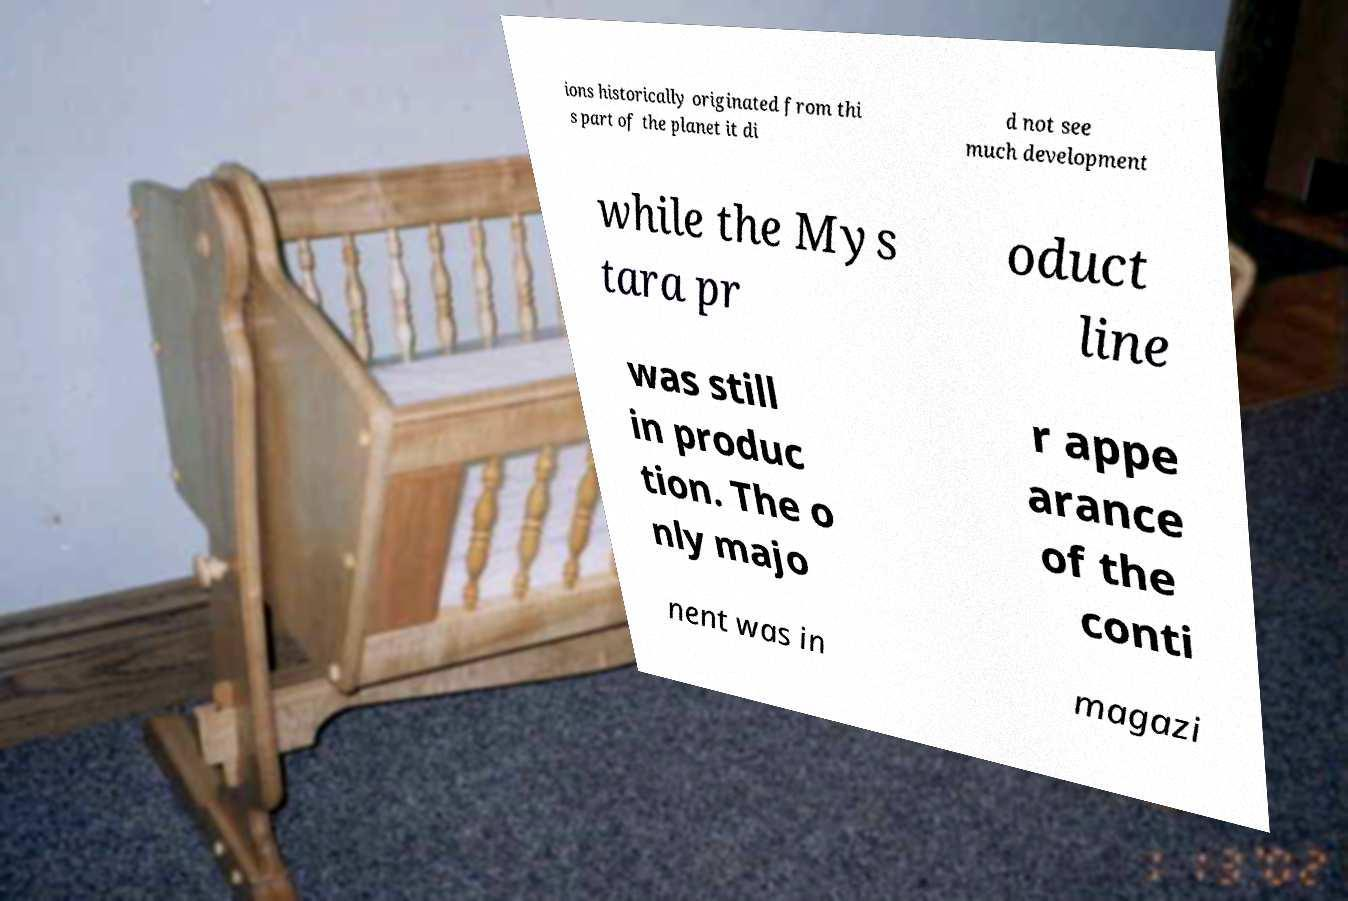I need the written content from this picture converted into text. Can you do that? ions historically originated from thi s part of the planet it di d not see much development while the Mys tara pr oduct line was still in produc tion. The o nly majo r appe arance of the conti nent was in magazi 